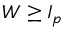Convert formula to latex. <formula><loc_0><loc_0><loc_500><loc_500>W \geq I _ { p }</formula> 